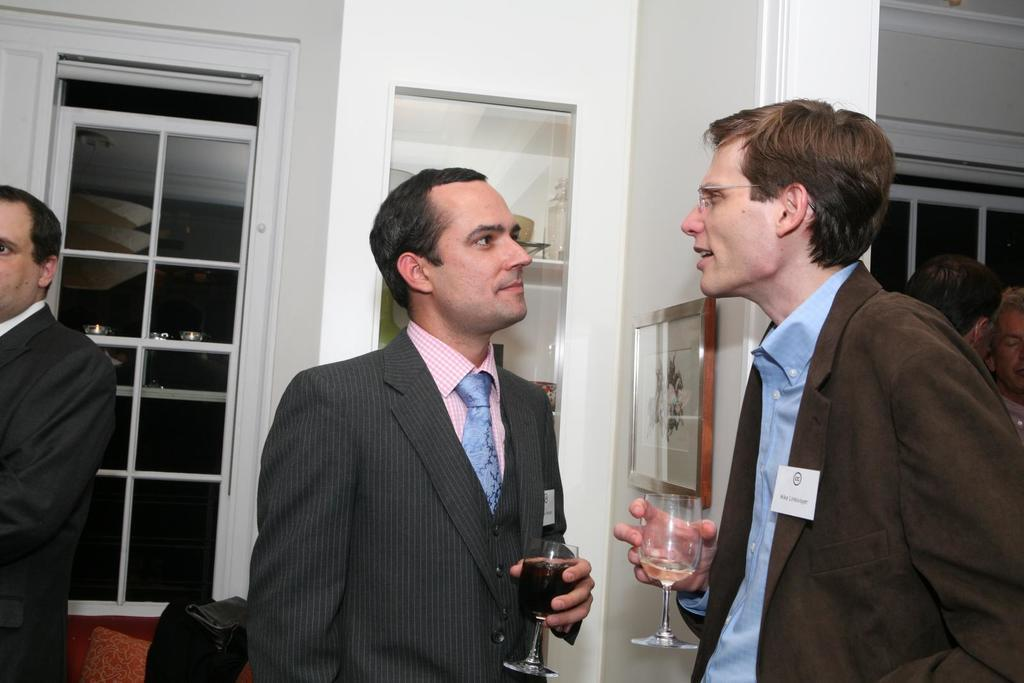How many people are in the image? There are two persons in the image. What are the persons doing in the image? The persons are standing and holding glasses in their hands. What can be seen in the background of the image? There is a glass door and a photo frame on the wall in the background of the image. What type of coal is visible in the image? There is no coal present in the image. What is the price of the photo frame in the image? The price of the photo frame is not visible in the image. 